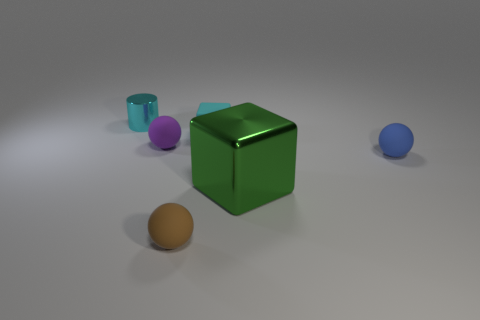What does the arrangement of these objects suggest about their context or purpose? The objects are spaced apart on a neutral background, which might indicate that this is a 3D rendering or artistic composition meant to display the objects themselves, perhaps as part of a study in form, lighting, and color. Their distribution does not suggest an immediate functional relationship, pointing instead to a focus on visual aesthetics or instructional demonstration in geometry. 